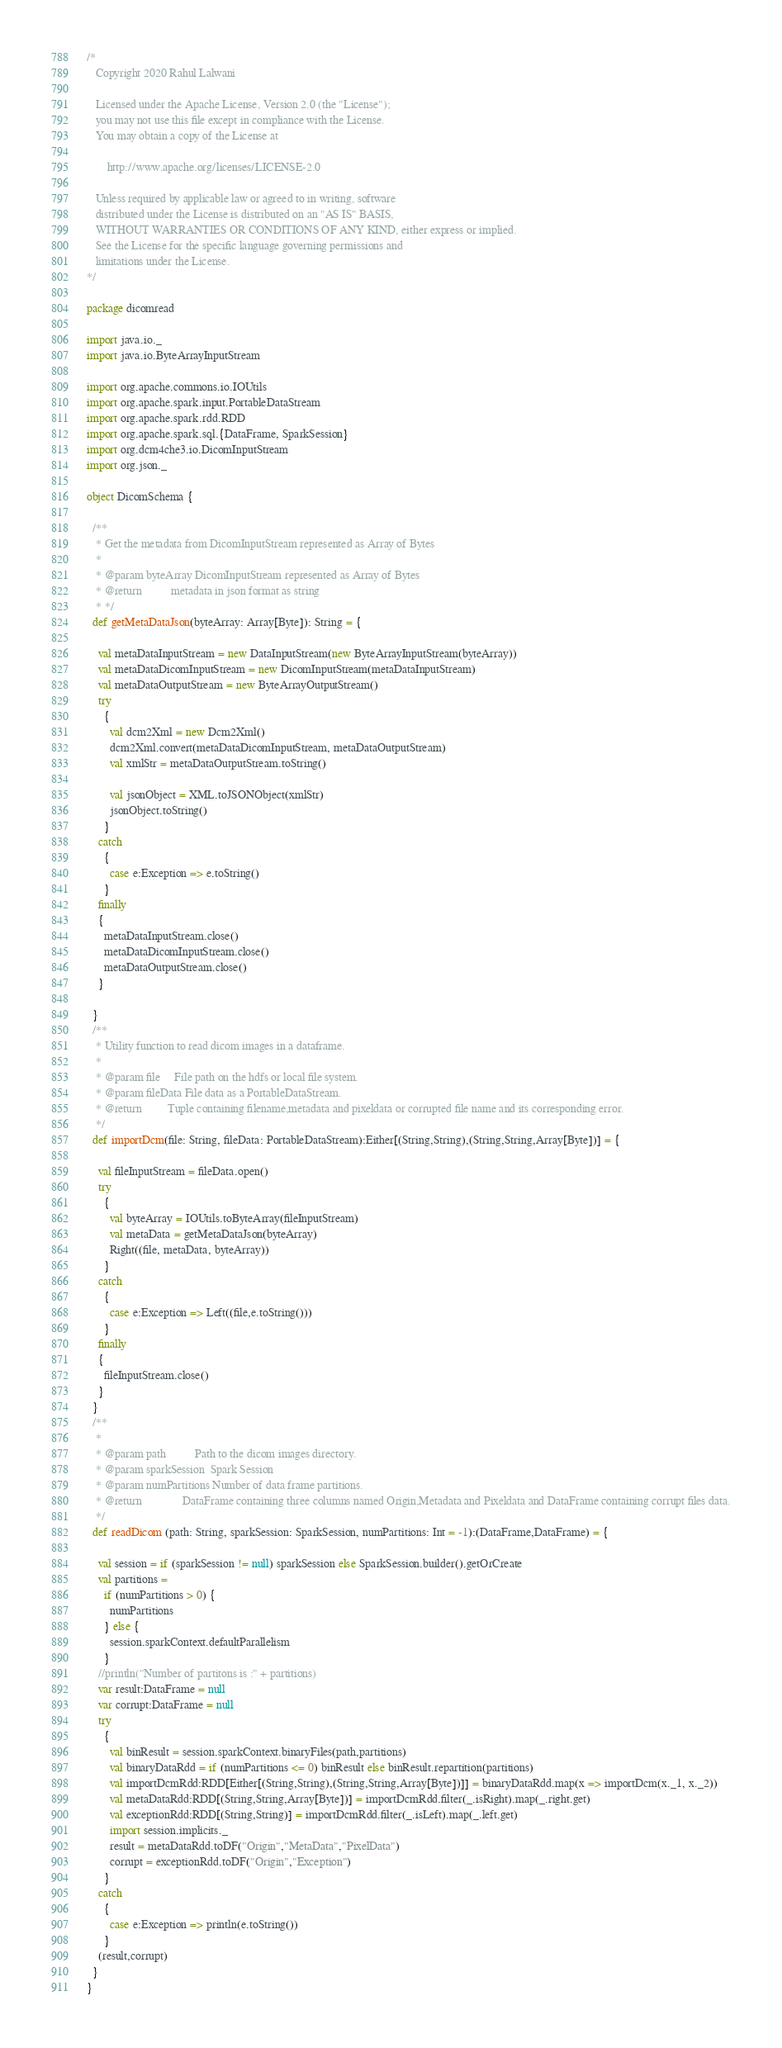Convert code to text. <code><loc_0><loc_0><loc_500><loc_500><_Scala_>/*
   Copyright 2020 Rahul Lalwani

   Licensed under the Apache License, Version 2.0 (the "License");
   you may not use this file except in compliance with the License.
   You may obtain a copy of the License at

       http://www.apache.org/licenses/LICENSE-2.0

   Unless required by applicable law or agreed to in writing, software
   distributed under the License is distributed on an "AS IS" BASIS,
   WITHOUT WARRANTIES OR CONDITIONS OF ANY KIND, either express or implied.
   See the License for the specific language governing permissions and
   limitations under the License.
*/

package dicomread

import java.io._
import java.io.ByteArrayInputStream

import org.apache.commons.io.IOUtils
import org.apache.spark.input.PortableDataStream
import org.apache.spark.rdd.RDD
import org.apache.spark.sql.{DataFrame, SparkSession}
import org.dcm4che3.io.DicomInputStream
import org.json._

object DicomSchema {

  /**
   * Get the metadata from DicomInputStream represented as Array of Bytes
   *
   * @param byteArray DicomInputStream represented as Array of Bytes
   * @return          metadata in json format as string
   * */
  def getMetaDataJson(byteArray: Array[Byte]): String = {

    val metaDataInputStream = new DataInputStream(new ByteArrayInputStream(byteArray))
    val metaDataDicomInputStream = new DicomInputStream(metaDataInputStream)
    val metaDataOutputStream = new ByteArrayOutputStream()
    try
      {
        val dcm2Xml = new Dcm2Xml()
        dcm2Xml.convert(metaDataDicomInputStream, metaDataOutputStream)
        val xmlStr = metaDataOutputStream.toString()

        val jsonObject = XML.toJSONObject(xmlStr)
        jsonObject.toString()
      }
    catch
      {
        case e:Exception => e.toString()
      }
    finally
    {
      metaDataInputStream.close()
      metaDataDicomInputStream.close()
      metaDataOutputStream.close()
    }

  }
  /**
   * Utility function to read dicom images in a dataframe.
   *
   * @param file     File path on the hdfs or local file system.
   * @param fileData File data as a PortableDataStream.
   * @return         Tuple containing filename,metadata and pixeldata or corrupted file name and its corresponding error.
   */
  def importDcm(file: String, fileData: PortableDataStream):Either[(String,String),(String,String,Array[Byte])] = {

    val fileInputStream = fileData.open()
    try
      {
        val byteArray = IOUtils.toByteArray(fileInputStream)
        val metaData = getMetaDataJson(byteArray)
        Right((file, metaData, byteArray))
      }
    catch
      {
        case e:Exception => Left((file,e.toString()))
      }
    finally
    {
      fileInputStream.close()
    }
  }
  /**
   *
   * @param path          Path to the dicom images directory.
   * @param sparkSession  Spark Session
   * @param numPartitions Number of data frame partitions.
   * @return              DataFrame containing three columns named Origin,Metadata and Pixeldata and DataFrame containing corrupt files data.
   */
  def readDicom (path: String, sparkSession: SparkSession, numPartitions: Int = -1):(DataFrame,DataFrame) = {

    val session = if (sparkSession != null) sparkSession else SparkSession.builder().getOrCreate
    val partitions =
      if (numPartitions > 0) {
        numPartitions
      } else {
        session.sparkContext.defaultParallelism
      }
    //println("Number of partitons is :" + partitions)
    var result:DataFrame = null
    var corrupt:DataFrame = null
    try
      {
        val binResult = session.sparkContext.binaryFiles(path,partitions)
        val binaryDataRdd = if (numPartitions <= 0) binResult else binResult.repartition(partitions)
        val importDcmRdd:RDD[Either[(String,String),(String,String,Array[Byte])]] = binaryDataRdd.map(x => importDcm(x._1, x._2))
        val metaDataRdd:RDD[(String,String,Array[Byte])] = importDcmRdd.filter(_.isRight).map(_.right.get)
        val exceptionRdd:RDD[(String,String)] = importDcmRdd.filter(_.isLeft).map(_.left.get)
        import session.implicits._
        result = metaDataRdd.toDF("Origin","MetaData","PixelData")
        corrupt = exceptionRdd.toDF("Origin","Exception")
      }
    catch
      {
        case e:Exception => println(e.toString())
      }
    (result,corrupt)
  }
}</code> 